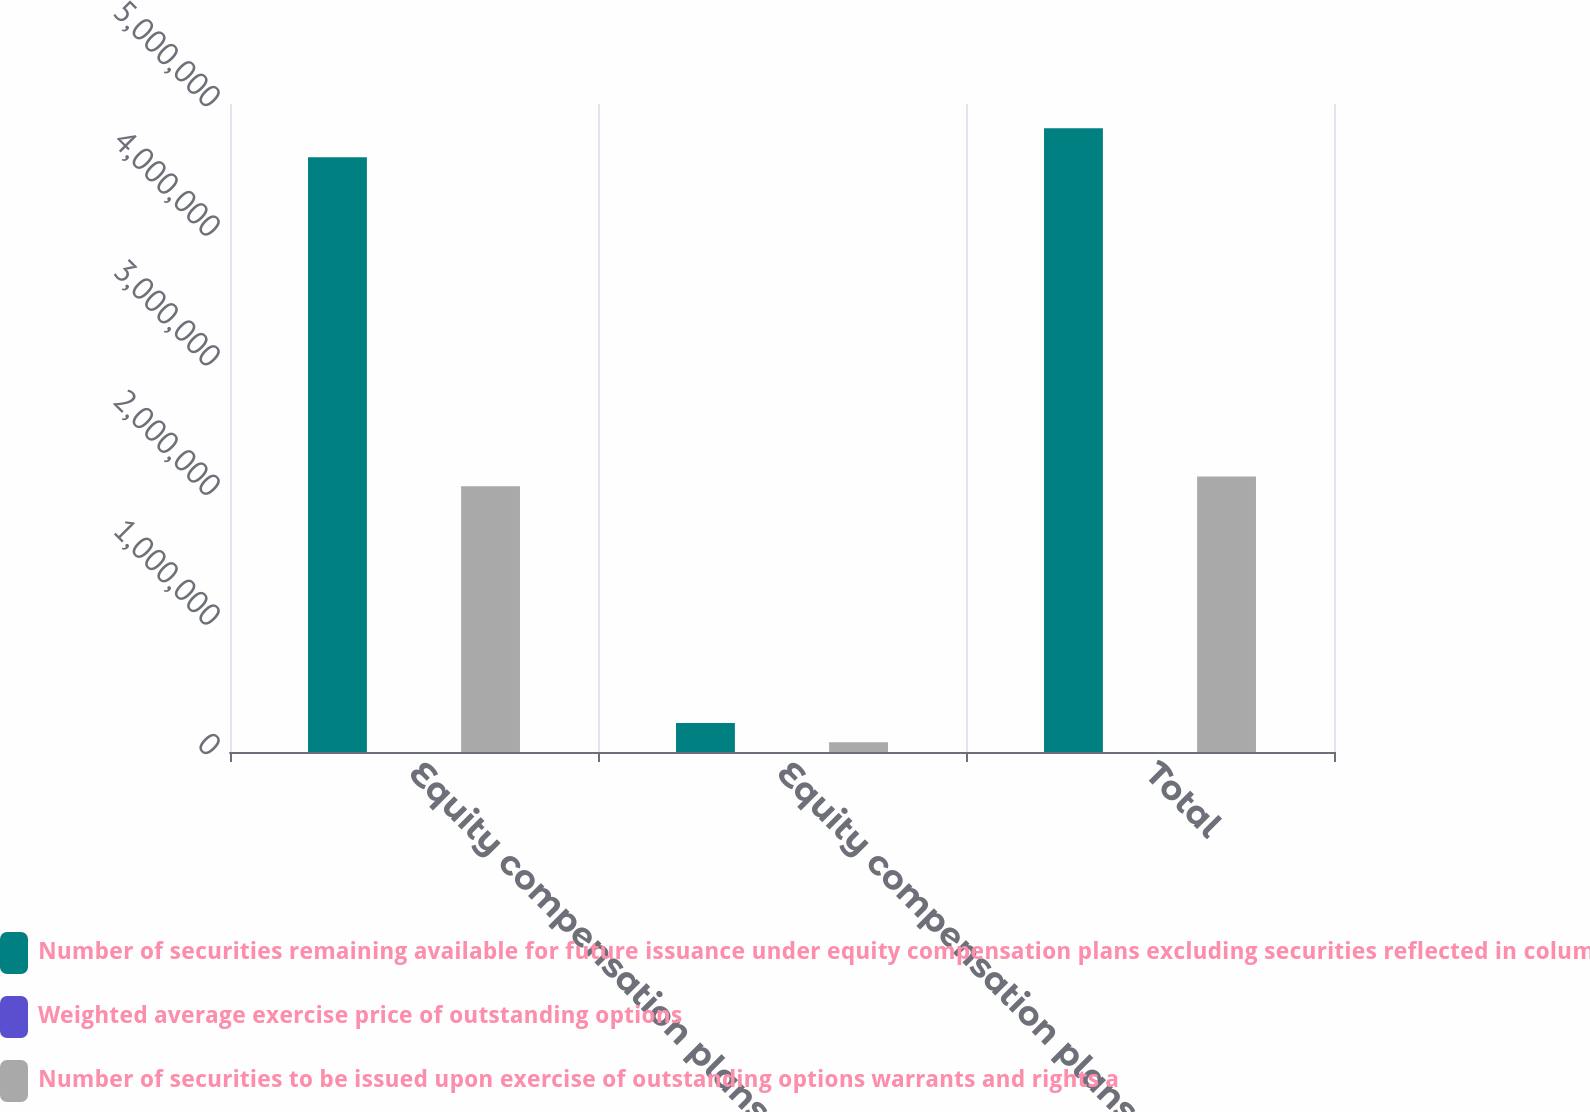Convert chart. <chart><loc_0><loc_0><loc_500><loc_500><stacked_bar_chart><ecel><fcel>Equity compensation plans<fcel>Equity compensation plans not<fcel>Total<nl><fcel>Number of securities remaining available for future issuance under equity compensation plans excluding securities reflected in column a<fcel>4.58838e+06<fcel>224694<fcel>4.81307e+06<nl><fcel>Weighted average exercise price of outstanding options<fcel>204.42<fcel>303.2<fcel>209.03<nl><fcel>Number of securities to be issued upon exercise of outstanding options warrants and rights a<fcel>2.05053e+06<fcel>75306<fcel>2.12583e+06<nl></chart> 